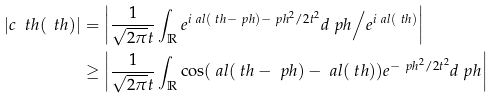<formula> <loc_0><loc_0><loc_500><loc_500>| c _ { \ } t h ( \ t h ) | & = \left | \frac { 1 } { \sqrt { 2 \pi } t } \int _ { \mathbb { R } } e ^ { i \ a l ( \ t h - \ p h ) - \ p h ^ { 2 } / 2 t ^ { 2 } } d \ p h \Big / e ^ { i \ a l ( \ t h ) } \right | \\ & \geq \left | \frac { 1 } { \sqrt { 2 \pi } t } \int _ { \mathbb { R } } \cos ( \ a l ( \ t h - \ p h ) - \ a l ( \ t h ) ) e ^ { - \ p h ^ { 2 } / 2 t ^ { 2 } } d \ p h \right |</formula> 